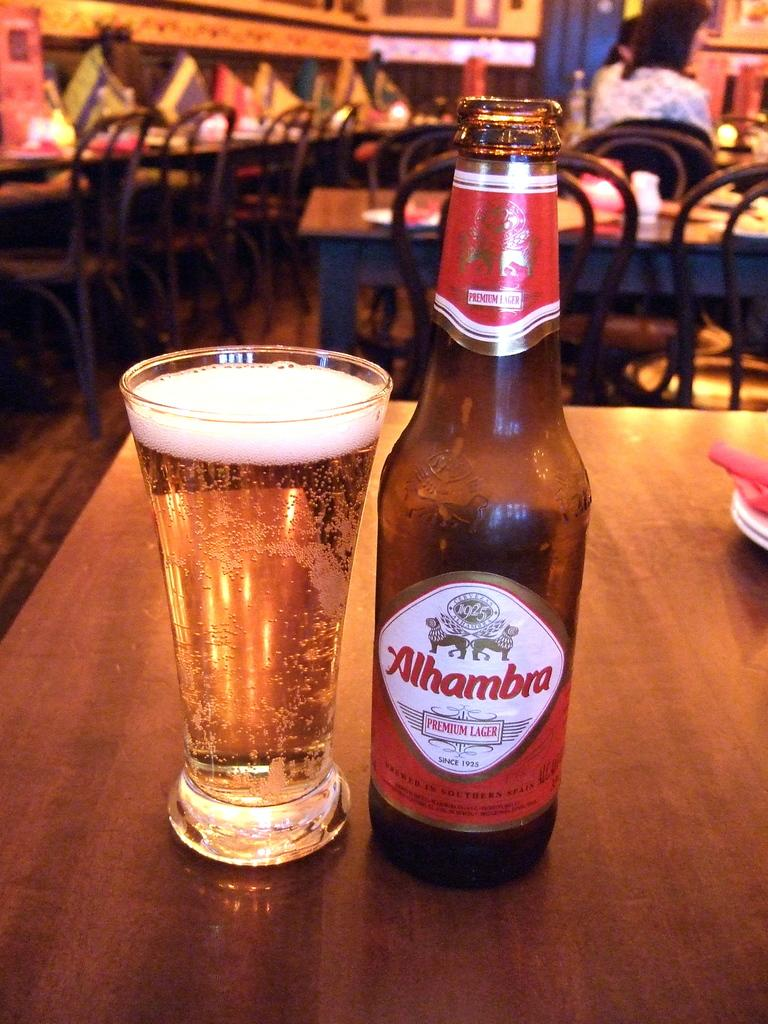<image>
Render a clear and concise summary of the photo. A bottle of Alhambra lager sits next to the cup it was poured into on a table in a restaurant. 